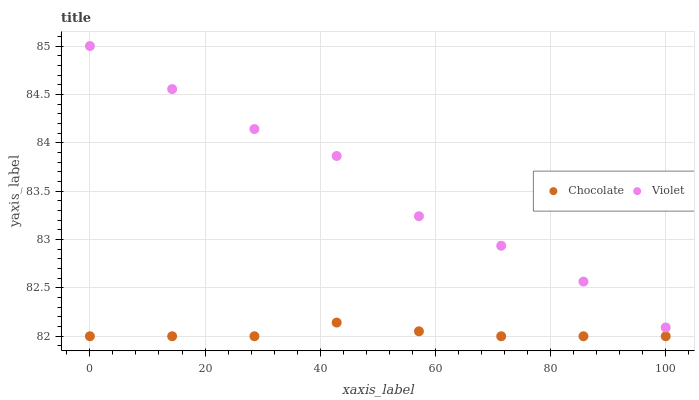Does Chocolate have the minimum area under the curve?
Answer yes or no. Yes. Does Violet have the maximum area under the curve?
Answer yes or no. Yes. Does Chocolate have the maximum area under the curve?
Answer yes or no. No. Is Chocolate the smoothest?
Answer yes or no. Yes. Is Violet the roughest?
Answer yes or no. Yes. Is Chocolate the roughest?
Answer yes or no. No. Does Chocolate have the lowest value?
Answer yes or no. Yes. Does Violet have the highest value?
Answer yes or no. Yes. Does Chocolate have the highest value?
Answer yes or no. No. Is Chocolate less than Violet?
Answer yes or no. Yes. Is Violet greater than Chocolate?
Answer yes or no. Yes. Does Chocolate intersect Violet?
Answer yes or no. No. 